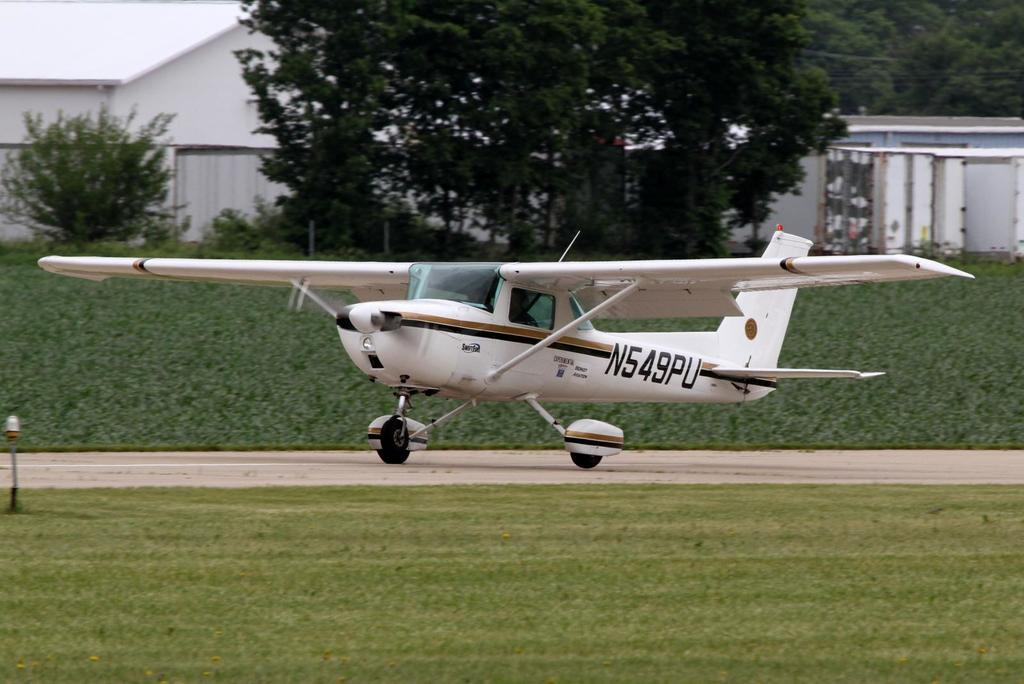<image>
Present a compact description of the photo's key features. A small plane witth the n549pu written on the tail. 